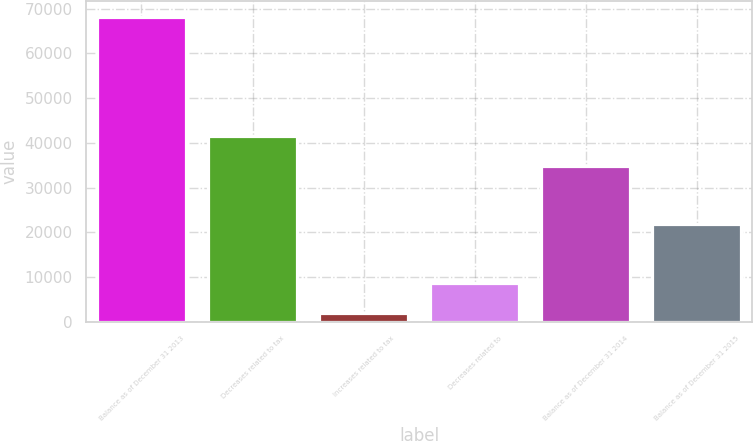<chart> <loc_0><loc_0><loc_500><loc_500><bar_chart><fcel>Balance as of December 31 2013<fcel>Decreases related to tax<fcel>Increases related to tax<fcel>Decreases related to<fcel>Balance as of December 31 2014<fcel>Balance as of December 31 2015<nl><fcel>68231<fcel>41439.1<fcel>1960<fcel>8587.1<fcel>34812<fcel>21841.3<nl></chart> 